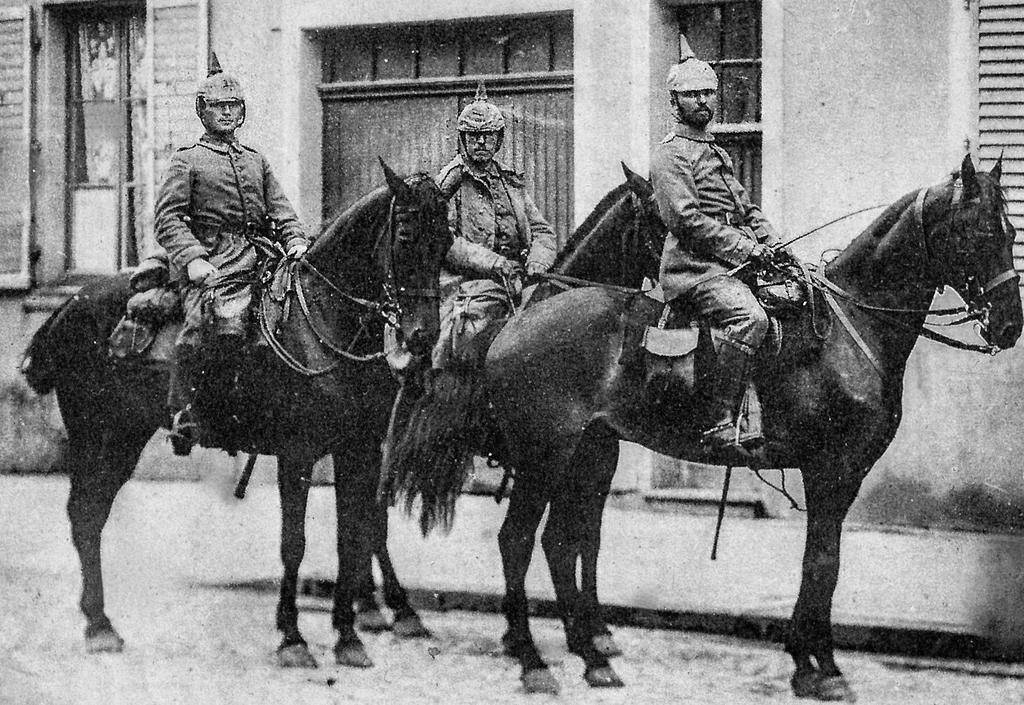How many people are in the image? There are three persons in the image. What are the people wearing on their heads? Each person is wearing a cap. What are the people doing in the image? Each person is sitting on a horse. What can be seen in the background of the image? There is a building in the background of the image. What type of truck can be seen in the image? There is no truck present in the image. Is there a crook in the image trying to steal the horses? There is no crook or any indication of theft in the image; the people are simply sitting on their horses. 